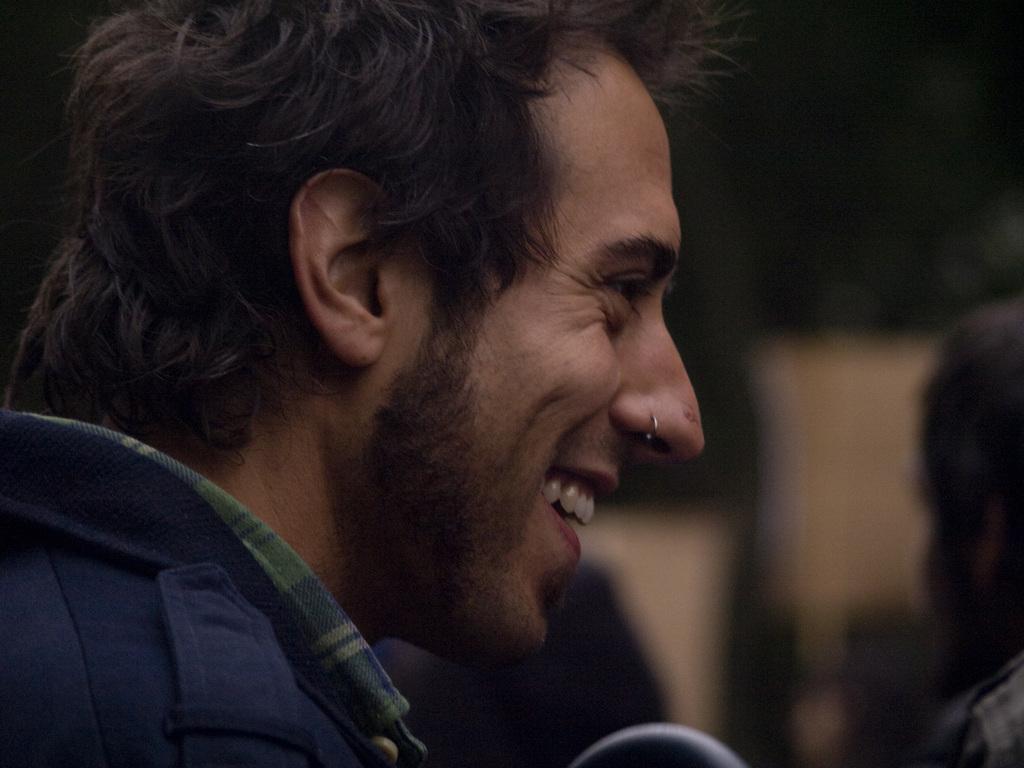How would you summarize this image in a sentence or two? In this image we can see a person. The background of the image is blurred. To the right side of the image there is another person. 